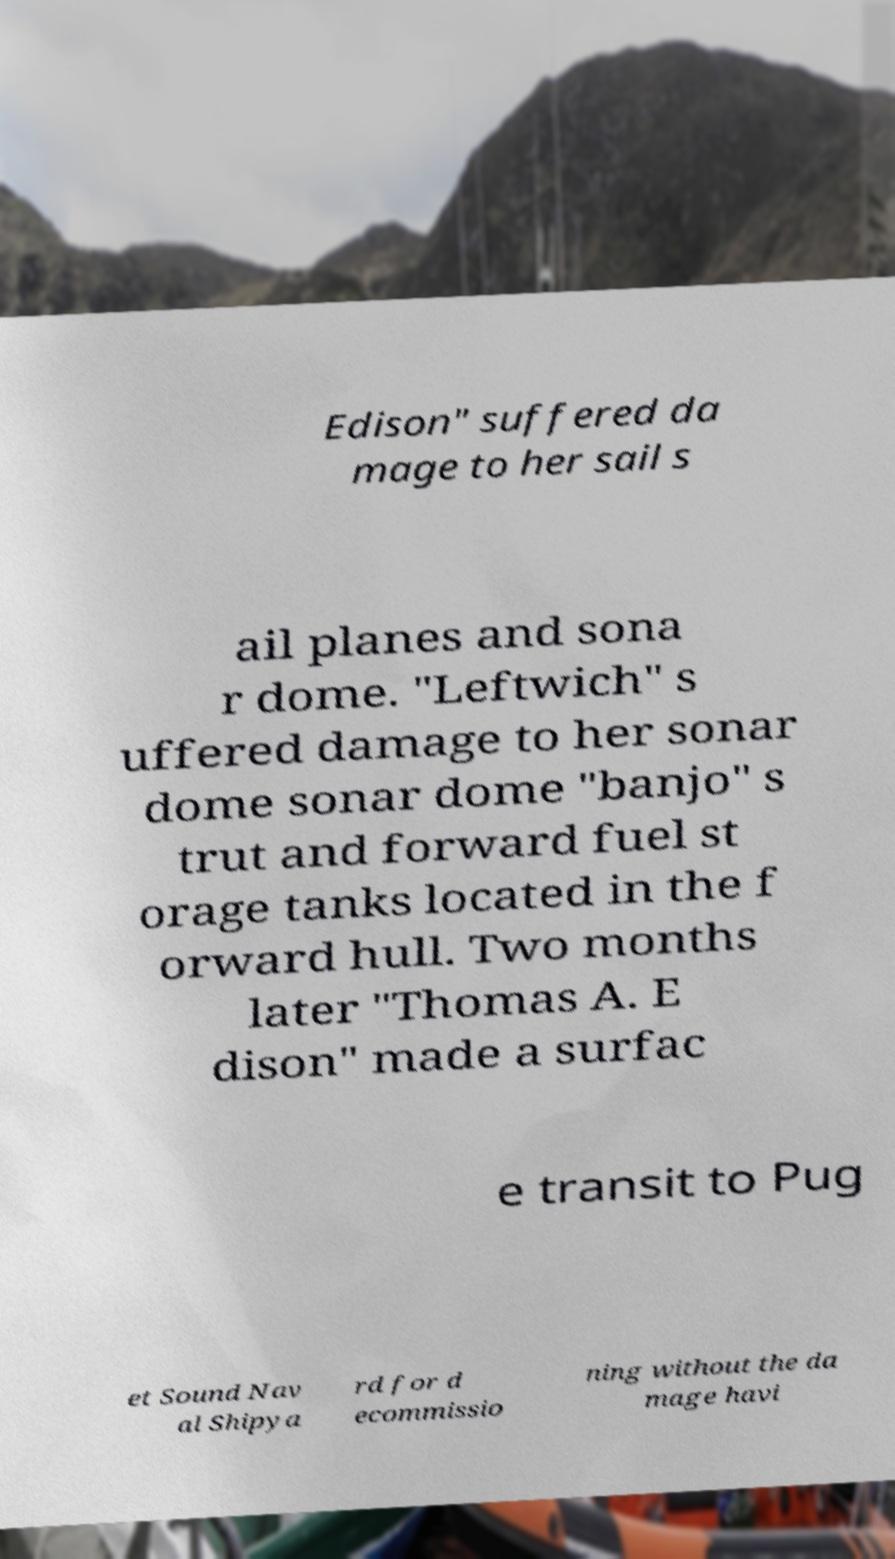I need the written content from this picture converted into text. Can you do that? Edison" suffered da mage to her sail s ail planes and sona r dome. "Leftwich" s uffered damage to her sonar dome sonar dome "banjo" s trut and forward fuel st orage tanks located in the f orward hull. Two months later "Thomas A. E dison" made a surfac e transit to Pug et Sound Nav al Shipya rd for d ecommissio ning without the da mage havi 